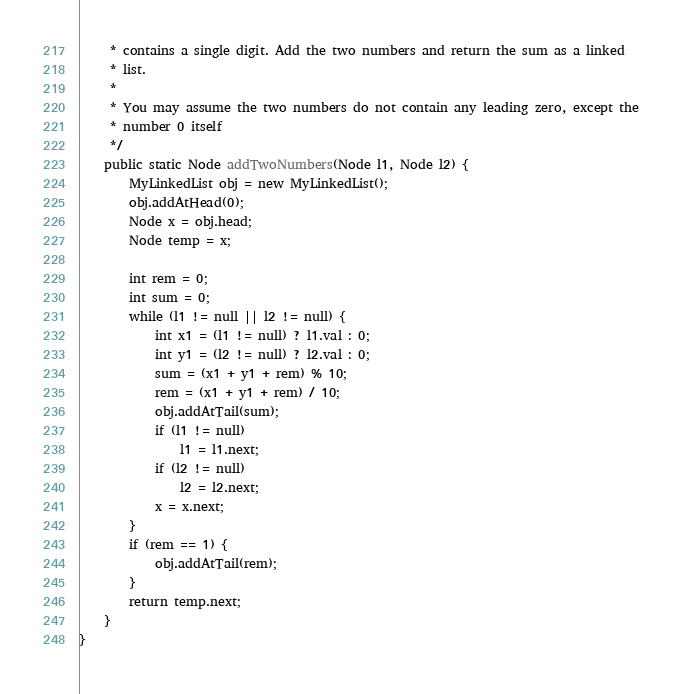<code> <loc_0><loc_0><loc_500><loc_500><_Java_>	 * contains a single digit. Add the two numbers and return the sum as a linked
	 * list.
	 * 
	 * You may assume the two numbers do not contain any leading zero, except the
	 * number 0 itself
	 */
	public static Node addTwoNumbers(Node l1, Node l2) {
		MyLinkedList obj = new MyLinkedList();
		obj.addAtHead(0);
		Node x = obj.head;
		Node temp = x;

		int rem = 0;
		int sum = 0;
		while (l1 != null || l2 != null) {
			int x1 = (l1 != null) ? l1.val : 0;
			int y1 = (l2 != null) ? l2.val : 0;
			sum = (x1 + y1 + rem) % 10;
			rem = (x1 + y1 + rem) / 10;
			obj.addAtTail(sum);
			if (l1 != null)
				l1 = l1.next;
			if (l2 != null)
				l2 = l2.next;
			x = x.next;
		}
		if (rem == 1) {
			obj.addAtTail(rem);
		}
		return temp.next;
	}
}
</code> 